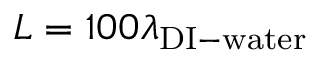<formula> <loc_0><loc_0><loc_500><loc_500>L = 1 0 0 \lambda _ { D I - w a t e r }</formula> 